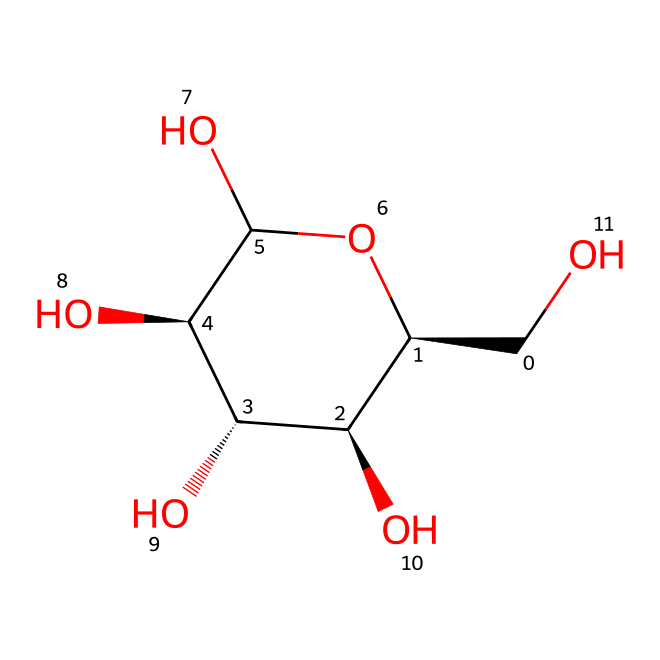How many carbon atoms are in glucose? The SMILES representation indicates that glucose has six carbon atoms, as can be counted from the structure (C).
Answer: six What is the functional group present in glucose? Analyzing the structure, glucose contains multiple hydroxyl (–OH) groups, which are indicative of alcohols and carbohydrates.
Answer: hydroxyl What type of carbohydrate is glucose? Based on its structure, glucose is classified as a monosaccharide, which is the simplest form of carbohydrates.
Answer: monosaccharide What is the total number of hydroxyl groups in glucose? By inspecting the structure, there are five hydroxyl (–OH) groups present on the glucose molecule.
Answer: five How many stereocenters are present in glucose? In the given structure, there are four carbon atoms that are bonded to four different groups, indicating four stereocenters.
Answer: four What is the molecular formula of glucose? By calculating based on the SMILES representation and counting the atoms, the molecular formula can be determined as C6H12O6.
Answer: C6H12O6 What type of bond connects the carbon atoms in glucose? The structure shows that carbon atoms are connected by single covalent bonds throughout the glucose molecule.
Answer: single covalent 